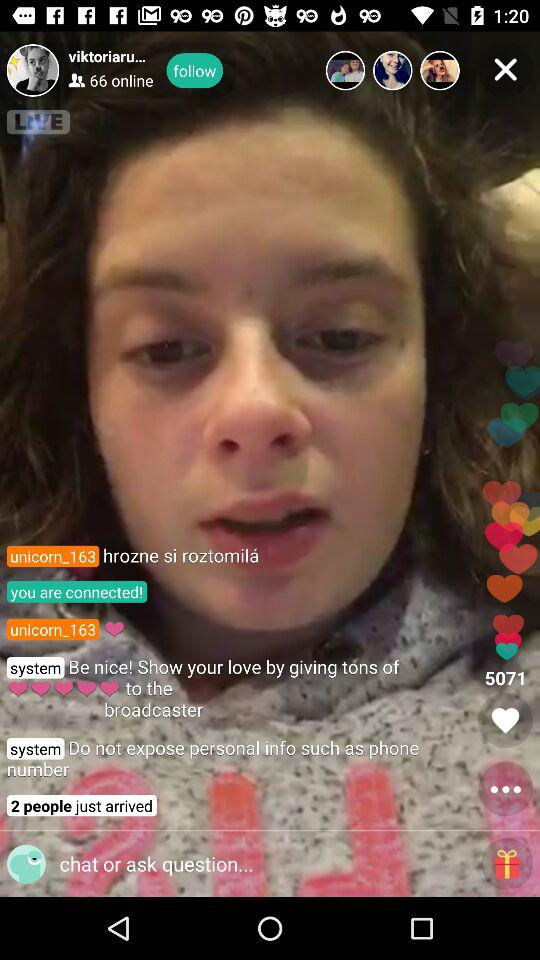What is the username? The usernames are "viktoriaru..." and "unicorn_163". 